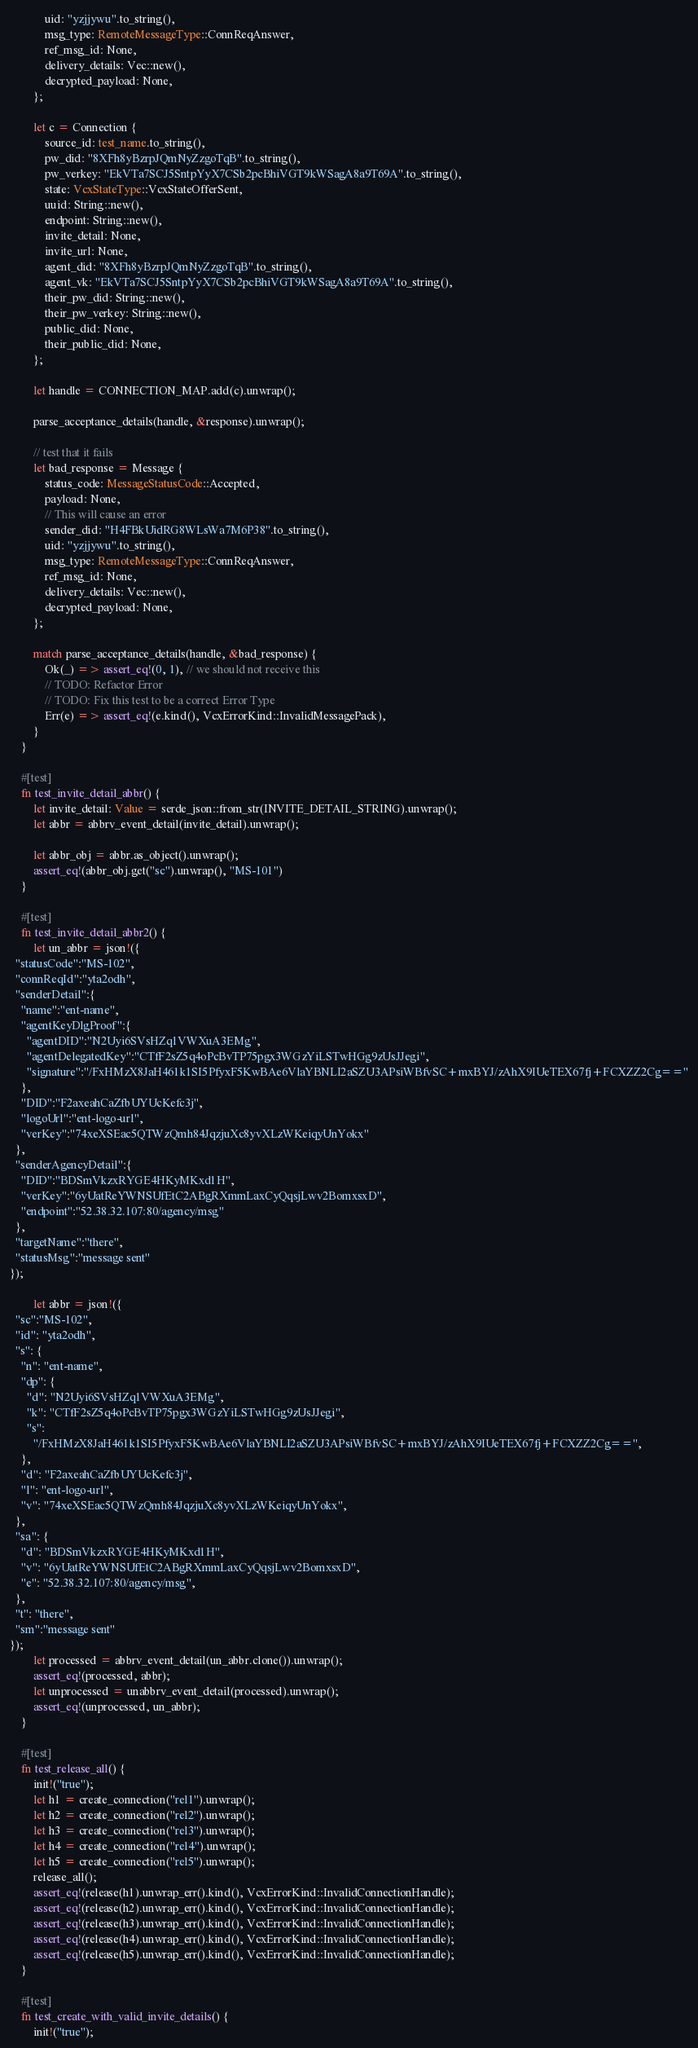Convert code to text. <code><loc_0><loc_0><loc_500><loc_500><_Rust_>            uid: "yzjjywu".to_string(),
            msg_type: RemoteMessageType::ConnReqAnswer,
            ref_msg_id: None,
            delivery_details: Vec::new(),
            decrypted_payload: None,
        };

        let c = Connection {
            source_id: test_name.to_string(),
            pw_did: "8XFh8yBzrpJQmNyZzgoTqB".to_string(),
            pw_verkey: "EkVTa7SCJ5SntpYyX7CSb2pcBhiVGT9kWSagA8a9T69A".to_string(),
            state: VcxStateType::VcxStateOfferSent,
            uuid: String::new(),
            endpoint: String::new(),
            invite_detail: None,
            invite_url: None,
            agent_did: "8XFh8yBzrpJQmNyZzgoTqB".to_string(),
            agent_vk: "EkVTa7SCJ5SntpYyX7CSb2pcBhiVGT9kWSagA8a9T69A".to_string(),
            their_pw_did: String::new(),
            their_pw_verkey: String::new(),
            public_did: None,
            their_public_did: None,
        };

        let handle = CONNECTION_MAP.add(c).unwrap();

        parse_acceptance_details(handle, &response).unwrap();

        // test that it fails
        let bad_response = Message {
            status_code: MessageStatusCode::Accepted,
            payload: None,
            // This will cause an error
            sender_did: "H4FBkUidRG8WLsWa7M6P38".to_string(),
            uid: "yzjjywu".to_string(),
            msg_type: RemoteMessageType::ConnReqAnswer,
            ref_msg_id: None,
            delivery_details: Vec::new(),
            decrypted_payload: None,
        };

        match parse_acceptance_details(handle, &bad_response) {
            Ok(_) => assert_eq!(0, 1), // we should not receive this
            // TODO: Refactor Error
            // TODO: Fix this test to be a correct Error Type
            Err(e) => assert_eq!(e.kind(), VcxErrorKind::InvalidMessagePack),
        }
    }

    #[test]
    fn test_invite_detail_abbr() {
        let invite_detail: Value = serde_json::from_str(INVITE_DETAIL_STRING).unwrap();
        let abbr = abbrv_event_detail(invite_detail).unwrap();

        let abbr_obj = abbr.as_object().unwrap();
        assert_eq!(abbr_obj.get("sc").unwrap(), "MS-101")
    }

    #[test]
    fn test_invite_detail_abbr2() {
        let un_abbr = json!({
  "statusCode":"MS-102",
  "connReqId":"yta2odh",
  "senderDetail":{
    "name":"ent-name",
    "agentKeyDlgProof":{
      "agentDID":"N2Uyi6SVsHZq1VWXuA3EMg",
      "agentDelegatedKey":"CTfF2sZ5q4oPcBvTP75pgx3WGzYiLSTwHGg9zUsJJegi",
      "signature":"/FxHMzX8JaH461k1SI5PfyxF5KwBAe6VlaYBNLI2aSZU3APsiWBfvSC+mxBYJ/zAhX9IUeTEX67fj+FCXZZ2Cg=="
    },
    "DID":"F2axeahCaZfbUYUcKefc3j",
    "logoUrl":"ent-logo-url",
    "verKey":"74xeXSEac5QTWzQmh84JqzjuXc8yvXLzWKeiqyUnYokx"
  },
  "senderAgencyDetail":{
    "DID":"BDSmVkzxRYGE4HKyMKxd1H",
    "verKey":"6yUatReYWNSUfEtC2ABgRXmmLaxCyQqsjLwv2BomxsxD",
    "endpoint":"52.38.32.107:80/agency/msg"
  },
  "targetName":"there",
  "statusMsg":"message sent"
});

        let abbr = json!({
  "sc":"MS-102",
  "id": "yta2odh",
  "s": {
    "n": "ent-name",
    "dp": {
      "d": "N2Uyi6SVsHZq1VWXuA3EMg",
      "k": "CTfF2sZ5q4oPcBvTP75pgx3WGzYiLSTwHGg9zUsJJegi",
      "s":
        "/FxHMzX8JaH461k1SI5PfyxF5KwBAe6VlaYBNLI2aSZU3APsiWBfvSC+mxBYJ/zAhX9IUeTEX67fj+FCXZZ2Cg==",
    },
    "d": "F2axeahCaZfbUYUcKefc3j",
    "l": "ent-logo-url",
    "v": "74xeXSEac5QTWzQmh84JqzjuXc8yvXLzWKeiqyUnYokx",
  },
  "sa": {
    "d": "BDSmVkzxRYGE4HKyMKxd1H",
    "v": "6yUatReYWNSUfEtC2ABgRXmmLaxCyQqsjLwv2BomxsxD",
    "e": "52.38.32.107:80/agency/msg",
  },
  "t": "there",
  "sm":"message sent"
});
        let processed = abbrv_event_detail(un_abbr.clone()).unwrap();
        assert_eq!(processed, abbr);
        let unprocessed = unabbrv_event_detail(processed).unwrap();
        assert_eq!(unprocessed, un_abbr);
    }

    #[test]
    fn test_release_all() {
        init!("true");
        let h1 = create_connection("rel1").unwrap();
        let h2 = create_connection("rel2").unwrap();
        let h3 = create_connection("rel3").unwrap();
        let h4 = create_connection("rel4").unwrap();
        let h5 = create_connection("rel5").unwrap();
        release_all();
        assert_eq!(release(h1).unwrap_err().kind(), VcxErrorKind::InvalidConnectionHandle);
        assert_eq!(release(h2).unwrap_err().kind(), VcxErrorKind::InvalidConnectionHandle);
        assert_eq!(release(h3).unwrap_err().kind(), VcxErrorKind::InvalidConnectionHandle);
        assert_eq!(release(h4).unwrap_err().kind(), VcxErrorKind::InvalidConnectionHandle);
        assert_eq!(release(h5).unwrap_err().kind(), VcxErrorKind::InvalidConnectionHandle);
    }

    #[test]
    fn test_create_with_valid_invite_details() {
        init!("true");
</code> 